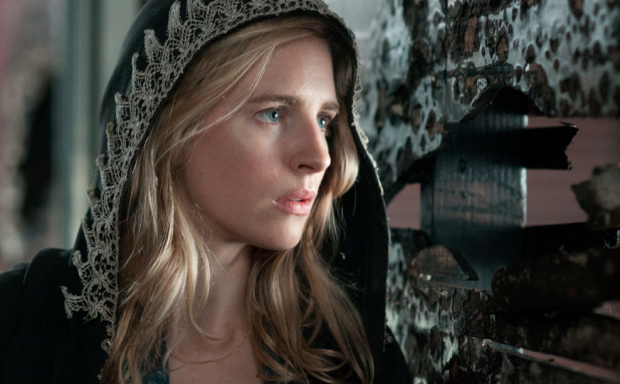What's happening in the scene? In the image, a woman is dressed in a black hooded cloak with elegant white lace trimming. The expression on her face indicates concern or deep thought, and her gaze is directed off to the side, suggesting she might be anxiously anticipating something or lost in contemplation. She stands against a backdrop of a wall adorned with peeling black and white posters, which contrasts strikingly with her dark attire. The scene conveys an atmosphere of mystery and intrigue, as if she is part of a narrative where something significant is about to happen. 